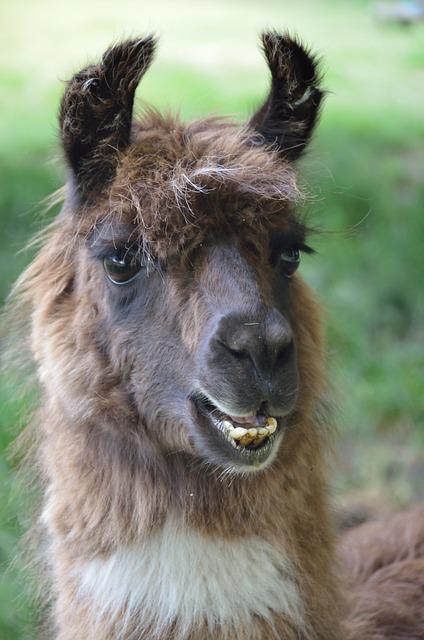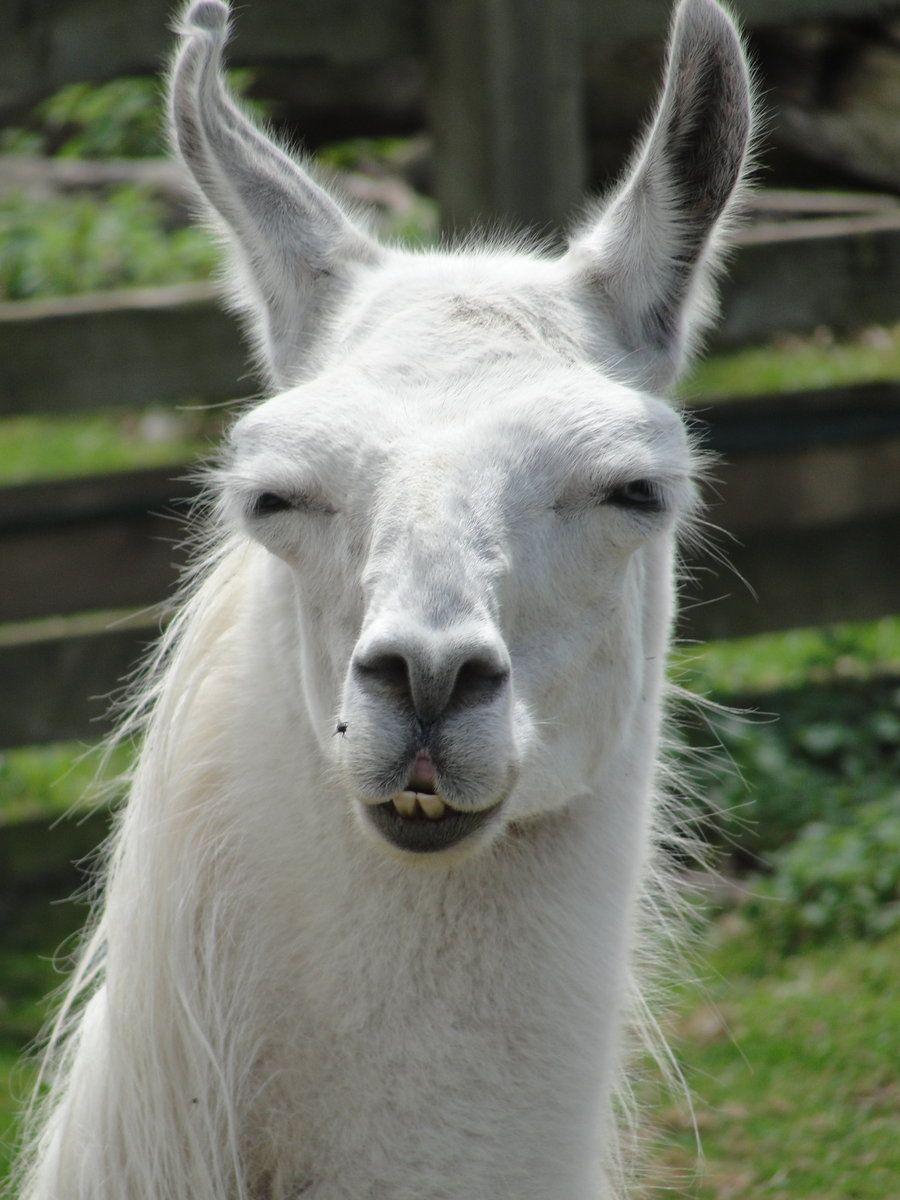The first image is the image on the left, the second image is the image on the right. For the images shown, is this caption "One image shows a forward-facing llama with dark ears and protruding lower teeth, and the other image shows a forward-facing white llama." true? Answer yes or no. Yes. 